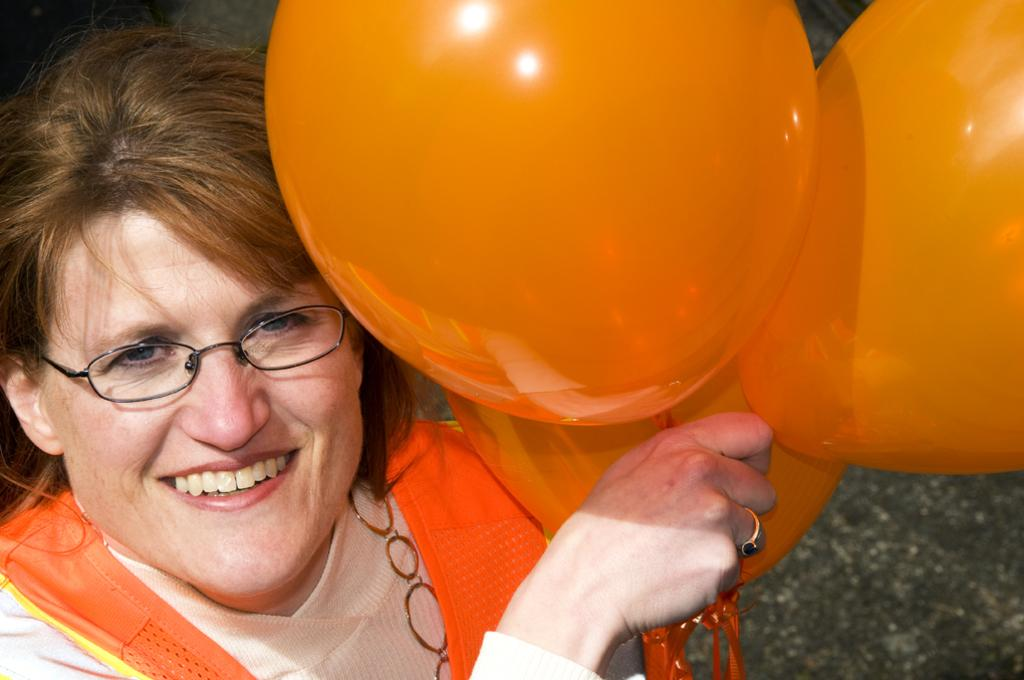Who is the main subject in the image? There is a lady in the image. What is the lady doing in the image? The lady is smiling. What accessory is the lady wearing in the image? The lady is wearing spectacles. What is the lady holding in her hand in the image? The lady is holding balloons in her hand. What piece of jewelry can be seen on the lady's finger in the image? There is a ring on the lady's finger. How many turkeys are present in the image? There are no turkeys present in the image. What type of operation is the lady performing in the image? The lady is not performing any operation in the image; she is simply smiling and holding balloons. 